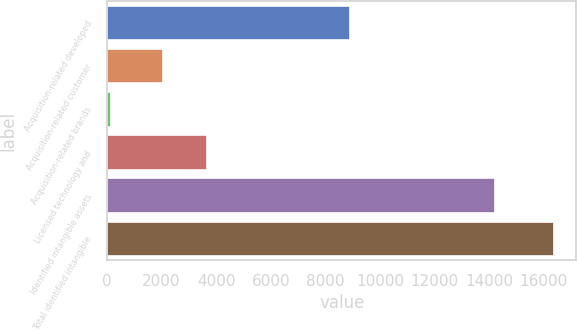<chart> <loc_0><loc_0><loc_500><loc_500><bar_chart><fcel>Acquisition-related developed<fcel>Acquisition-related customer<fcel>Acquisition-related brands<fcel>Licensed technology and<fcel>Identified intangible assets<fcel>Total identified intangible<nl><fcel>8912<fcel>2052<fcel>143<fcel>3675.6<fcel>14211<fcel>16379<nl></chart> 